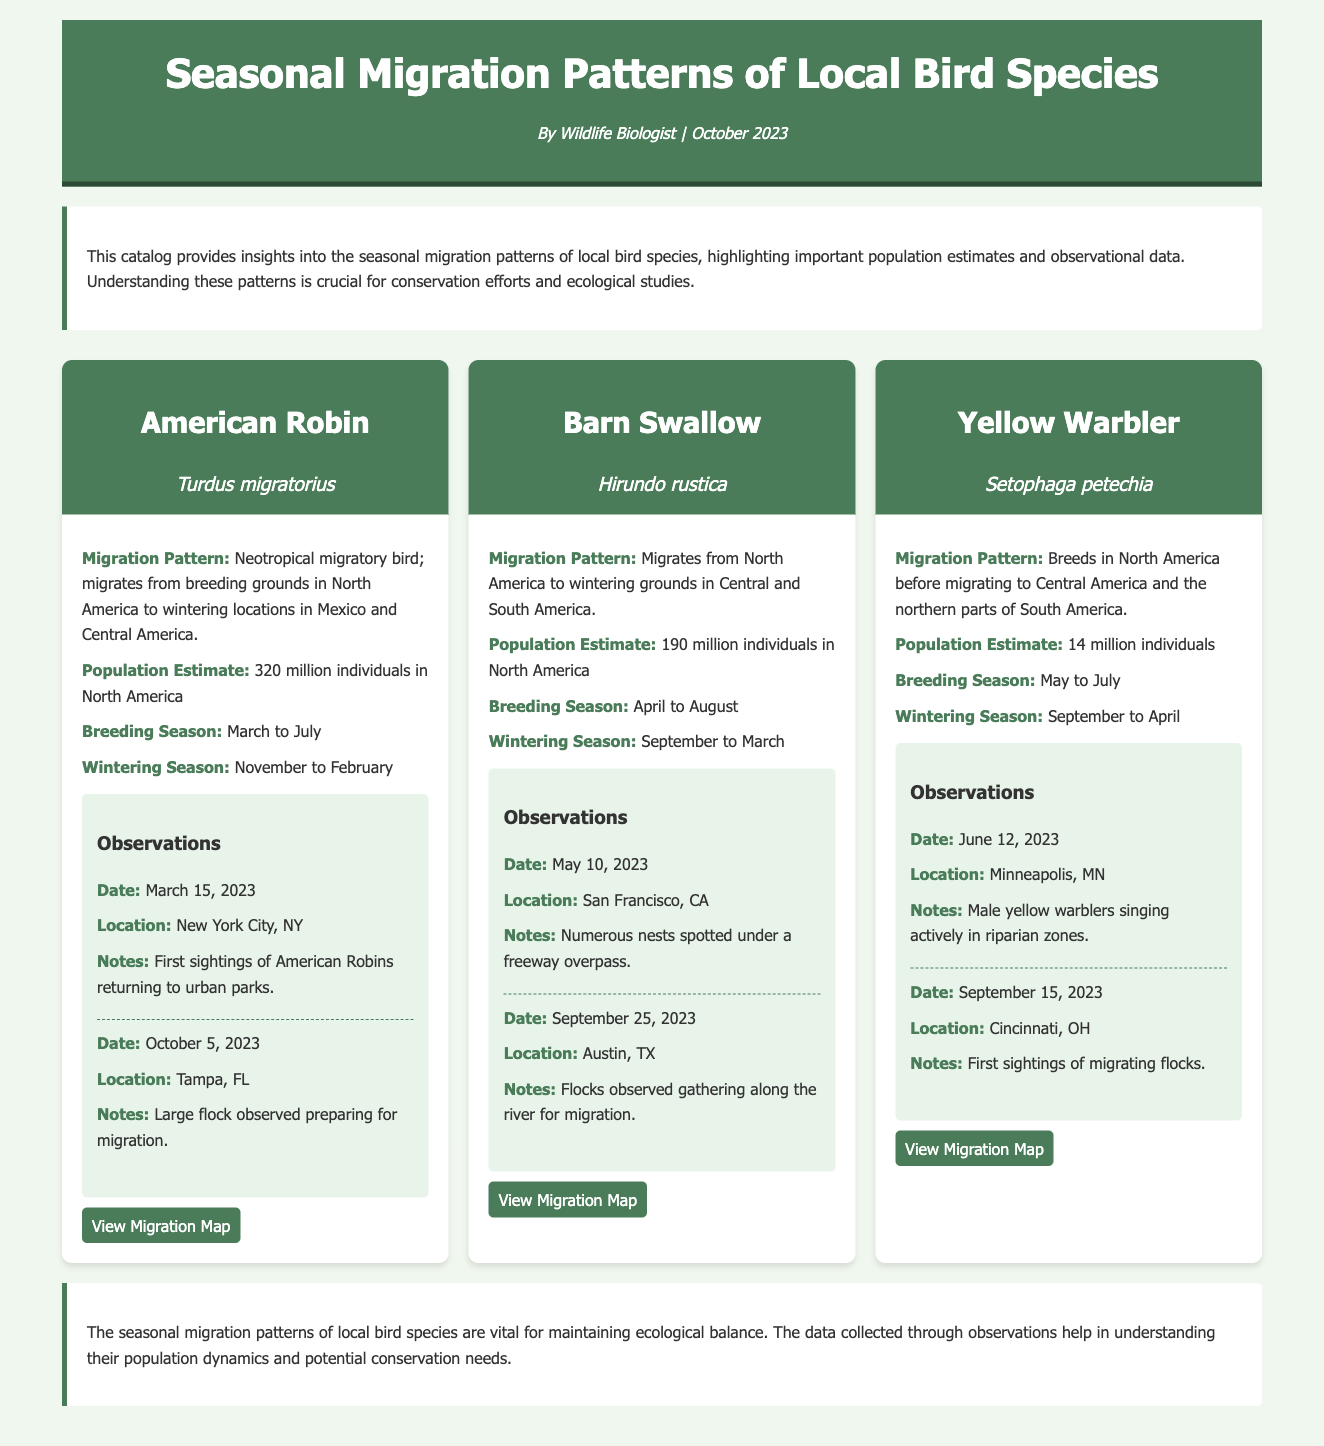What is the total population estimate for American Robins? The population estimate stated in the document for American Robins is provided directly in the content.
Answer: 320 million individuals in North America What is the breeding season for the Yellow Warbler? The breeding season for the Yellow Warbler is mentioned under its specific heading in the document.
Answer: May to July How many individuals are estimated for the Barn Swallow population? The document specifies the population estimate for Barn Swallows, which can be readily found in the data section.
Answer: 190 million individuals in North America When do American Robins winter? The wintering season for American Robins is included in their respective section within the document, indicating the months they spend in warmer regions.
Answer: November to February What is the migration pattern of the Barn Swallow? The migration pattern of the Barn Swallow outlines their migratory behavior and destinations in the document, making it easily identifiable.
Answer: Migrates from North America to wintering grounds in Central and South America What is the observation date for the first sightings of American Robins in New York City? This date is specifically listed under the observations for American Robins, allowing for a direct reference in the text.
Answer: March 15, 2023 Why are the seasonal migration patterns important? The significance of these patterns is explained in the conclusion of the document, highlighting their ecological role.
Answer: Vital for maintaining ecological balance What observation was made on June 12, 2023, regarding the Yellow Warbler? The specific observation details for the Yellow Warbler are documented, making this information easily retrievable from the text.
Answer: Male yellow warblers singing actively in riparian zones During which season do Barn Swallows typically migrate? The wintering season for Barn Swallows indicates when they leave their breeding grounds, directly stated in the document.
Answer: September to March 